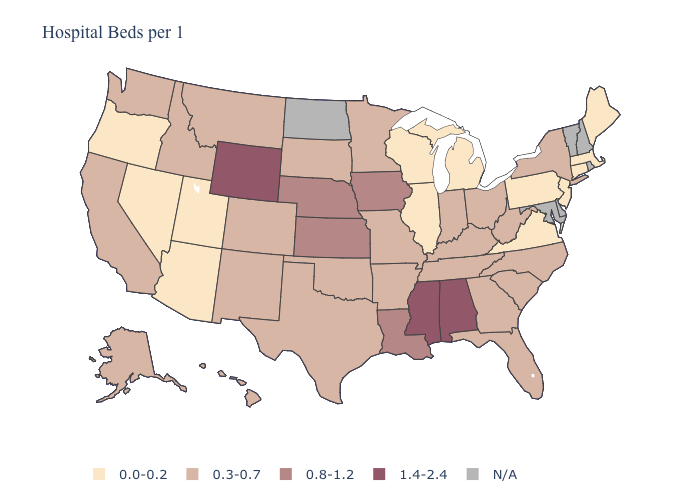Is the legend a continuous bar?
Quick response, please. No. What is the value of Pennsylvania?
Write a very short answer. 0.0-0.2. Which states have the lowest value in the USA?
Short answer required. Arizona, Connecticut, Illinois, Maine, Massachusetts, Michigan, Nevada, New Jersey, Oregon, Pennsylvania, Utah, Virginia, Wisconsin. Does Indiana have the lowest value in the MidWest?
Give a very brief answer. No. What is the lowest value in the USA?
Short answer required. 0.0-0.2. Name the states that have a value in the range N/A?
Keep it brief. Delaware, Maryland, New Hampshire, North Dakota, Rhode Island, Vermont. Name the states that have a value in the range 0.0-0.2?
Keep it brief. Arizona, Connecticut, Illinois, Maine, Massachusetts, Michigan, Nevada, New Jersey, Oregon, Pennsylvania, Utah, Virginia, Wisconsin. What is the lowest value in the South?
Short answer required. 0.0-0.2. Does Missouri have the highest value in the MidWest?
Quick response, please. No. What is the value of Iowa?
Concise answer only. 0.8-1.2. What is the value of Nebraska?
Quick response, please. 0.8-1.2. What is the highest value in states that border Wisconsin?
Short answer required. 0.8-1.2. What is the value of Maryland?
Write a very short answer. N/A. Which states have the highest value in the USA?
Give a very brief answer. Alabama, Mississippi, Wyoming. What is the highest value in the USA?
Be succinct. 1.4-2.4. 